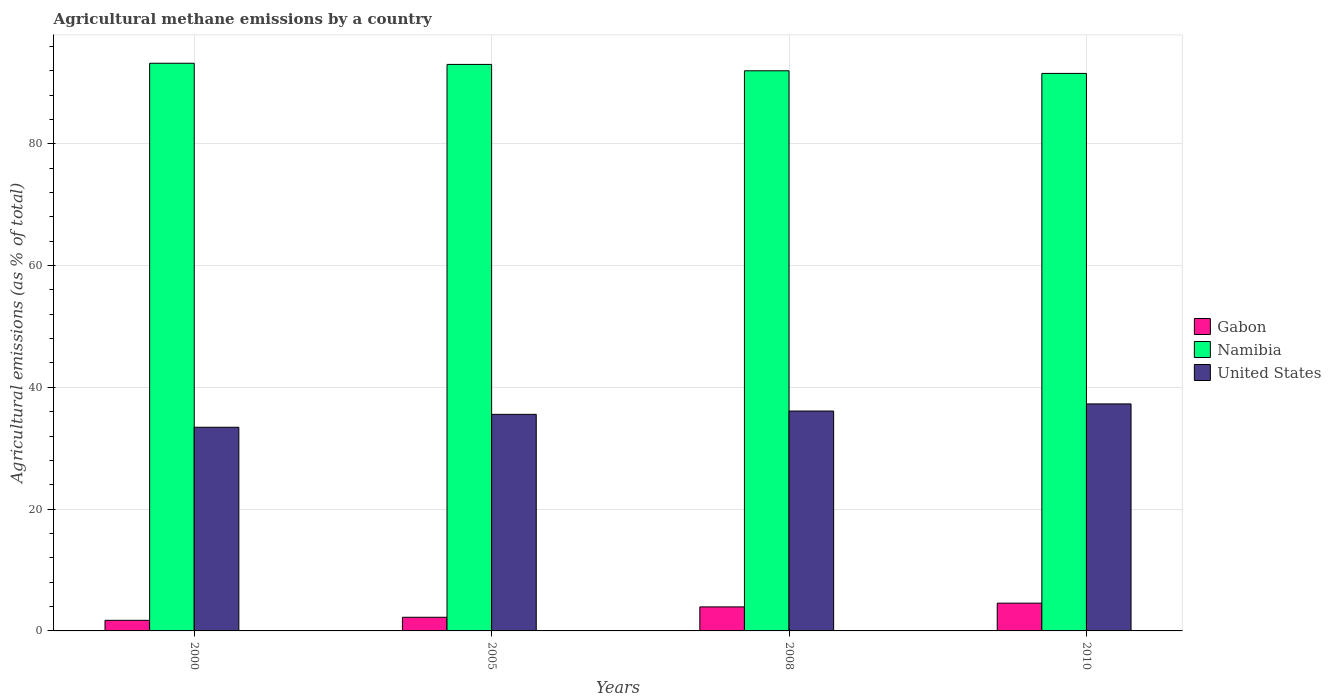How many different coloured bars are there?
Make the answer very short. 3. Are the number of bars on each tick of the X-axis equal?
Offer a terse response. Yes. How many bars are there on the 1st tick from the right?
Offer a terse response. 3. What is the label of the 1st group of bars from the left?
Your response must be concise. 2000. In how many cases, is the number of bars for a given year not equal to the number of legend labels?
Give a very brief answer. 0. What is the amount of agricultural methane emitted in Namibia in 2000?
Offer a terse response. 93.22. Across all years, what is the maximum amount of agricultural methane emitted in United States?
Give a very brief answer. 37.28. Across all years, what is the minimum amount of agricultural methane emitted in Gabon?
Offer a very short reply. 1.74. What is the total amount of agricultural methane emitted in Gabon in the graph?
Provide a short and direct response. 12.49. What is the difference between the amount of agricultural methane emitted in United States in 2000 and that in 2008?
Ensure brevity in your answer.  -2.66. What is the difference between the amount of agricultural methane emitted in Gabon in 2008 and the amount of agricultural methane emitted in Namibia in 2005?
Give a very brief answer. -89.09. What is the average amount of agricultural methane emitted in United States per year?
Your response must be concise. 35.6. In the year 2010, what is the difference between the amount of agricultural methane emitted in Gabon and amount of agricultural methane emitted in Namibia?
Offer a terse response. -87. In how many years, is the amount of agricultural methane emitted in Namibia greater than 60 %?
Make the answer very short. 4. What is the ratio of the amount of agricultural methane emitted in Gabon in 2000 to that in 2010?
Your answer should be compact. 0.38. Is the amount of agricultural methane emitted in United States in 2005 less than that in 2010?
Your answer should be compact. Yes. Is the difference between the amount of agricultural methane emitted in Gabon in 2000 and 2008 greater than the difference between the amount of agricultural methane emitted in Namibia in 2000 and 2008?
Keep it short and to the point. No. What is the difference between the highest and the second highest amount of agricultural methane emitted in Gabon?
Your response must be concise. 0.62. What is the difference between the highest and the lowest amount of agricultural methane emitted in United States?
Offer a terse response. 3.83. In how many years, is the amount of agricultural methane emitted in United States greater than the average amount of agricultural methane emitted in United States taken over all years?
Offer a very short reply. 2. Is the sum of the amount of agricultural methane emitted in United States in 2005 and 2008 greater than the maximum amount of agricultural methane emitted in Namibia across all years?
Offer a very short reply. No. What does the 2nd bar from the left in 2010 represents?
Provide a short and direct response. Namibia. What does the 1st bar from the right in 2005 represents?
Give a very brief answer. United States. Is it the case that in every year, the sum of the amount of agricultural methane emitted in Namibia and amount of agricultural methane emitted in Gabon is greater than the amount of agricultural methane emitted in United States?
Offer a terse response. Yes. Does the graph contain grids?
Your answer should be compact. Yes. Where does the legend appear in the graph?
Provide a short and direct response. Center right. How are the legend labels stacked?
Provide a short and direct response. Vertical. What is the title of the graph?
Your answer should be compact. Agricultural methane emissions by a country. Does "Palau" appear as one of the legend labels in the graph?
Offer a very short reply. No. What is the label or title of the X-axis?
Keep it short and to the point. Years. What is the label or title of the Y-axis?
Offer a terse response. Agricultural emissions (as % of total). What is the Agricultural emissions (as % of total) in Gabon in 2000?
Your answer should be very brief. 1.74. What is the Agricultural emissions (as % of total) in Namibia in 2000?
Your response must be concise. 93.22. What is the Agricultural emissions (as % of total) in United States in 2000?
Provide a short and direct response. 33.45. What is the Agricultural emissions (as % of total) of Gabon in 2005?
Offer a terse response. 2.24. What is the Agricultural emissions (as % of total) of Namibia in 2005?
Ensure brevity in your answer.  93.03. What is the Agricultural emissions (as % of total) in United States in 2005?
Ensure brevity in your answer.  35.56. What is the Agricultural emissions (as % of total) of Gabon in 2008?
Offer a very short reply. 3.94. What is the Agricultural emissions (as % of total) of Namibia in 2008?
Your answer should be compact. 91.99. What is the Agricultural emissions (as % of total) of United States in 2008?
Keep it short and to the point. 36.11. What is the Agricultural emissions (as % of total) in Gabon in 2010?
Ensure brevity in your answer.  4.56. What is the Agricultural emissions (as % of total) in Namibia in 2010?
Your response must be concise. 91.56. What is the Agricultural emissions (as % of total) of United States in 2010?
Your answer should be compact. 37.28. Across all years, what is the maximum Agricultural emissions (as % of total) in Gabon?
Keep it short and to the point. 4.56. Across all years, what is the maximum Agricultural emissions (as % of total) of Namibia?
Offer a very short reply. 93.22. Across all years, what is the maximum Agricultural emissions (as % of total) in United States?
Offer a terse response. 37.28. Across all years, what is the minimum Agricultural emissions (as % of total) of Gabon?
Ensure brevity in your answer.  1.74. Across all years, what is the minimum Agricultural emissions (as % of total) of Namibia?
Keep it short and to the point. 91.56. Across all years, what is the minimum Agricultural emissions (as % of total) of United States?
Provide a succinct answer. 33.45. What is the total Agricultural emissions (as % of total) of Gabon in the graph?
Keep it short and to the point. 12.49. What is the total Agricultural emissions (as % of total) in Namibia in the graph?
Give a very brief answer. 369.8. What is the total Agricultural emissions (as % of total) in United States in the graph?
Your answer should be compact. 142.4. What is the difference between the Agricultural emissions (as % of total) of Gabon in 2000 and that in 2005?
Offer a terse response. -0.5. What is the difference between the Agricultural emissions (as % of total) in Namibia in 2000 and that in 2005?
Your answer should be compact. 0.19. What is the difference between the Agricultural emissions (as % of total) of United States in 2000 and that in 2005?
Provide a succinct answer. -2.12. What is the difference between the Agricultural emissions (as % of total) in Gabon in 2000 and that in 2008?
Offer a very short reply. -2.2. What is the difference between the Agricultural emissions (as % of total) of Namibia in 2000 and that in 2008?
Your answer should be very brief. 1.24. What is the difference between the Agricultural emissions (as % of total) of United States in 2000 and that in 2008?
Keep it short and to the point. -2.66. What is the difference between the Agricultural emissions (as % of total) in Gabon in 2000 and that in 2010?
Offer a terse response. -2.82. What is the difference between the Agricultural emissions (as % of total) of Namibia in 2000 and that in 2010?
Make the answer very short. 1.67. What is the difference between the Agricultural emissions (as % of total) in United States in 2000 and that in 2010?
Provide a succinct answer. -3.83. What is the difference between the Agricultural emissions (as % of total) of Gabon in 2005 and that in 2008?
Your answer should be very brief. -1.7. What is the difference between the Agricultural emissions (as % of total) of Namibia in 2005 and that in 2008?
Your answer should be very brief. 1.05. What is the difference between the Agricultural emissions (as % of total) of United States in 2005 and that in 2008?
Offer a terse response. -0.54. What is the difference between the Agricultural emissions (as % of total) of Gabon in 2005 and that in 2010?
Provide a short and direct response. -2.32. What is the difference between the Agricultural emissions (as % of total) of Namibia in 2005 and that in 2010?
Give a very brief answer. 1.48. What is the difference between the Agricultural emissions (as % of total) in United States in 2005 and that in 2010?
Provide a short and direct response. -1.71. What is the difference between the Agricultural emissions (as % of total) in Gabon in 2008 and that in 2010?
Your response must be concise. -0.62. What is the difference between the Agricultural emissions (as % of total) of Namibia in 2008 and that in 2010?
Your response must be concise. 0.43. What is the difference between the Agricultural emissions (as % of total) in United States in 2008 and that in 2010?
Your answer should be very brief. -1.17. What is the difference between the Agricultural emissions (as % of total) of Gabon in 2000 and the Agricultural emissions (as % of total) of Namibia in 2005?
Your answer should be very brief. -91.29. What is the difference between the Agricultural emissions (as % of total) of Gabon in 2000 and the Agricultural emissions (as % of total) of United States in 2005?
Offer a terse response. -33.82. What is the difference between the Agricultural emissions (as % of total) in Namibia in 2000 and the Agricultural emissions (as % of total) in United States in 2005?
Your answer should be very brief. 57.66. What is the difference between the Agricultural emissions (as % of total) of Gabon in 2000 and the Agricultural emissions (as % of total) of Namibia in 2008?
Make the answer very short. -90.25. What is the difference between the Agricultural emissions (as % of total) of Gabon in 2000 and the Agricultural emissions (as % of total) of United States in 2008?
Provide a succinct answer. -34.37. What is the difference between the Agricultural emissions (as % of total) in Namibia in 2000 and the Agricultural emissions (as % of total) in United States in 2008?
Provide a short and direct response. 57.11. What is the difference between the Agricultural emissions (as % of total) in Gabon in 2000 and the Agricultural emissions (as % of total) in Namibia in 2010?
Provide a short and direct response. -89.81. What is the difference between the Agricultural emissions (as % of total) in Gabon in 2000 and the Agricultural emissions (as % of total) in United States in 2010?
Offer a terse response. -35.54. What is the difference between the Agricultural emissions (as % of total) in Namibia in 2000 and the Agricultural emissions (as % of total) in United States in 2010?
Your response must be concise. 55.94. What is the difference between the Agricultural emissions (as % of total) in Gabon in 2005 and the Agricultural emissions (as % of total) in Namibia in 2008?
Give a very brief answer. -89.75. What is the difference between the Agricultural emissions (as % of total) of Gabon in 2005 and the Agricultural emissions (as % of total) of United States in 2008?
Make the answer very short. -33.87. What is the difference between the Agricultural emissions (as % of total) of Namibia in 2005 and the Agricultural emissions (as % of total) of United States in 2008?
Ensure brevity in your answer.  56.92. What is the difference between the Agricultural emissions (as % of total) in Gabon in 2005 and the Agricultural emissions (as % of total) in Namibia in 2010?
Your answer should be very brief. -89.32. What is the difference between the Agricultural emissions (as % of total) of Gabon in 2005 and the Agricultural emissions (as % of total) of United States in 2010?
Your answer should be very brief. -35.04. What is the difference between the Agricultural emissions (as % of total) of Namibia in 2005 and the Agricultural emissions (as % of total) of United States in 2010?
Provide a short and direct response. 55.75. What is the difference between the Agricultural emissions (as % of total) in Gabon in 2008 and the Agricultural emissions (as % of total) in Namibia in 2010?
Your response must be concise. -87.61. What is the difference between the Agricultural emissions (as % of total) of Gabon in 2008 and the Agricultural emissions (as % of total) of United States in 2010?
Your answer should be very brief. -33.33. What is the difference between the Agricultural emissions (as % of total) in Namibia in 2008 and the Agricultural emissions (as % of total) in United States in 2010?
Provide a succinct answer. 54.71. What is the average Agricultural emissions (as % of total) of Gabon per year?
Provide a short and direct response. 3.12. What is the average Agricultural emissions (as % of total) of Namibia per year?
Ensure brevity in your answer.  92.45. What is the average Agricultural emissions (as % of total) of United States per year?
Your response must be concise. 35.6. In the year 2000, what is the difference between the Agricultural emissions (as % of total) of Gabon and Agricultural emissions (as % of total) of Namibia?
Provide a short and direct response. -91.48. In the year 2000, what is the difference between the Agricultural emissions (as % of total) in Gabon and Agricultural emissions (as % of total) in United States?
Give a very brief answer. -31.7. In the year 2000, what is the difference between the Agricultural emissions (as % of total) of Namibia and Agricultural emissions (as % of total) of United States?
Keep it short and to the point. 59.78. In the year 2005, what is the difference between the Agricultural emissions (as % of total) of Gabon and Agricultural emissions (as % of total) of Namibia?
Make the answer very short. -90.79. In the year 2005, what is the difference between the Agricultural emissions (as % of total) of Gabon and Agricultural emissions (as % of total) of United States?
Your answer should be compact. -33.32. In the year 2005, what is the difference between the Agricultural emissions (as % of total) in Namibia and Agricultural emissions (as % of total) in United States?
Provide a succinct answer. 57.47. In the year 2008, what is the difference between the Agricultural emissions (as % of total) in Gabon and Agricultural emissions (as % of total) in Namibia?
Keep it short and to the point. -88.04. In the year 2008, what is the difference between the Agricultural emissions (as % of total) of Gabon and Agricultural emissions (as % of total) of United States?
Provide a short and direct response. -32.17. In the year 2008, what is the difference between the Agricultural emissions (as % of total) of Namibia and Agricultural emissions (as % of total) of United States?
Make the answer very short. 55.88. In the year 2010, what is the difference between the Agricultural emissions (as % of total) in Gabon and Agricultural emissions (as % of total) in Namibia?
Ensure brevity in your answer.  -87. In the year 2010, what is the difference between the Agricultural emissions (as % of total) in Gabon and Agricultural emissions (as % of total) in United States?
Offer a very short reply. -32.72. In the year 2010, what is the difference between the Agricultural emissions (as % of total) of Namibia and Agricultural emissions (as % of total) of United States?
Give a very brief answer. 54.28. What is the ratio of the Agricultural emissions (as % of total) in Gabon in 2000 to that in 2005?
Give a very brief answer. 0.78. What is the ratio of the Agricultural emissions (as % of total) in United States in 2000 to that in 2005?
Provide a succinct answer. 0.94. What is the ratio of the Agricultural emissions (as % of total) of Gabon in 2000 to that in 2008?
Your answer should be compact. 0.44. What is the ratio of the Agricultural emissions (as % of total) in Namibia in 2000 to that in 2008?
Your response must be concise. 1.01. What is the ratio of the Agricultural emissions (as % of total) of United States in 2000 to that in 2008?
Your answer should be very brief. 0.93. What is the ratio of the Agricultural emissions (as % of total) in Gabon in 2000 to that in 2010?
Offer a very short reply. 0.38. What is the ratio of the Agricultural emissions (as % of total) of Namibia in 2000 to that in 2010?
Your answer should be compact. 1.02. What is the ratio of the Agricultural emissions (as % of total) of United States in 2000 to that in 2010?
Ensure brevity in your answer.  0.9. What is the ratio of the Agricultural emissions (as % of total) in Gabon in 2005 to that in 2008?
Offer a very short reply. 0.57. What is the ratio of the Agricultural emissions (as % of total) in Namibia in 2005 to that in 2008?
Make the answer very short. 1.01. What is the ratio of the Agricultural emissions (as % of total) in United States in 2005 to that in 2008?
Provide a short and direct response. 0.98. What is the ratio of the Agricultural emissions (as % of total) in Gabon in 2005 to that in 2010?
Provide a short and direct response. 0.49. What is the ratio of the Agricultural emissions (as % of total) in Namibia in 2005 to that in 2010?
Provide a short and direct response. 1.02. What is the ratio of the Agricultural emissions (as % of total) in United States in 2005 to that in 2010?
Offer a terse response. 0.95. What is the ratio of the Agricultural emissions (as % of total) in Gabon in 2008 to that in 2010?
Offer a very short reply. 0.86. What is the ratio of the Agricultural emissions (as % of total) of United States in 2008 to that in 2010?
Your answer should be compact. 0.97. What is the difference between the highest and the second highest Agricultural emissions (as % of total) in Gabon?
Your answer should be very brief. 0.62. What is the difference between the highest and the second highest Agricultural emissions (as % of total) of Namibia?
Your answer should be very brief. 0.19. What is the difference between the highest and the second highest Agricultural emissions (as % of total) in United States?
Make the answer very short. 1.17. What is the difference between the highest and the lowest Agricultural emissions (as % of total) of Gabon?
Ensure brevity in your answer.  2.82. What is the difference between the highest and the lowest Agricultural emissions (as % of total) of Namibia?
Your answer should be very brief. 1.67. What is the difference between the highest and the lowest Agricultural emissions (as % of total) of United States?
Your response must be concise. 3.83. 